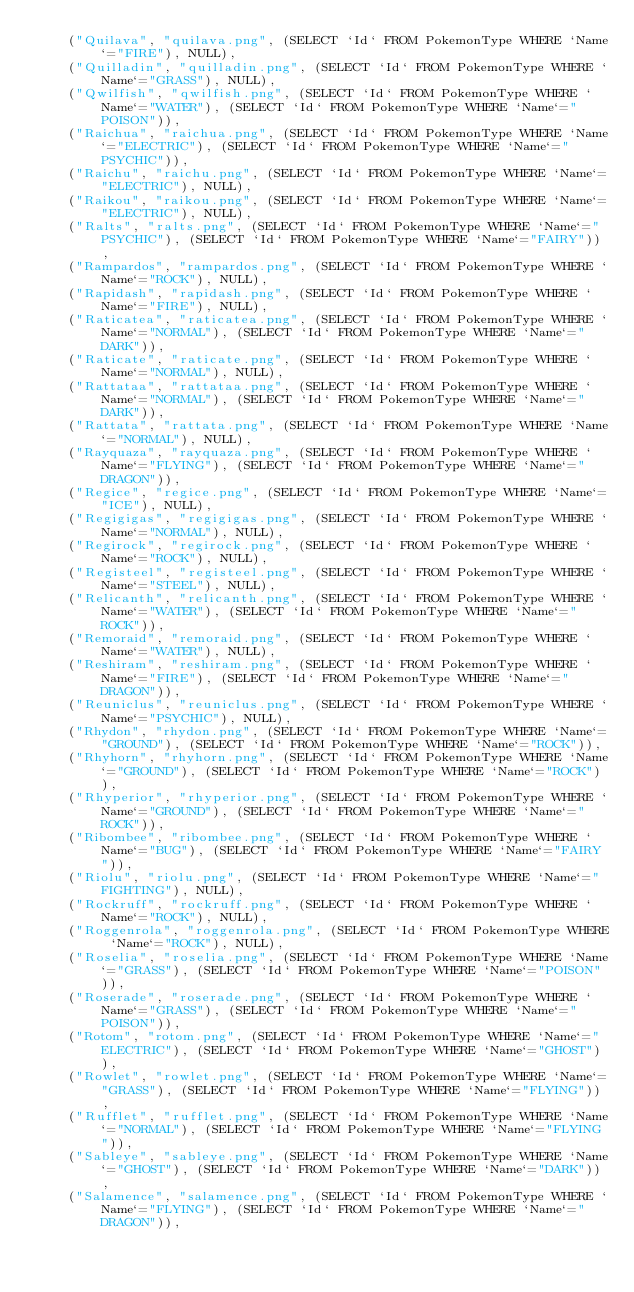<code> <loc_0><loc_0><loc_500><loc_500><_SQL_>	("Quilava", "quilava.png", (SELECT `Id` FROM PokemonType WHERE `Name`="FIRE"), NULL),
	("Quilladin", "quilladin.png", (SELECT `Id` FROM PokemonType WHERE `Name`="GRASS"), NULL),
	("Qwilfish", "qwilfish.png", (SELECT `Id` FROM PokemonType WHERE `Name`="WATER"), (SELECT `Id` FROM PokemonType WHERE `Name`="POISON")),
	("Raichua", "raichua.png", (SELECT `Id` FROM PokemonType WHERE `Name`="ELECTRIC"), (SELECT `Id` FROM PokemonType WHERE `Name`="PSYCHIC")),
	("Raichu", "raichu.png", (SELECT `Id` FROM PokemonType WHERE `Name`="ELECTRIC"), NULL),
	("Raikou", "raikou.png", (SELECT `Id` FROM PokemonType WHERE `Name`="ELECTRIC"), NULL),
	("Ralts", "ralts.png", (SELECT `Id` FROM PokemonType WHERE `Name`="PSYCHIC"), (SELECT `Id` FROM PokemonType WHERE `Name`="FAIRY")),
	("Rampardos", "rampardos.png", (SELECT `Id` FROM PokemonType WHERE `Name`="ROCK"), NULL),
	("Rapidash", "rapidash.png", (SELECT `Id` FROM PokemonType WHERE `Name`="FIRE"), NULL),
	("Raticatea", "raticatea.png", (SELECT `Id` FROM PokemonType WHERE `Name`="NORMAL"), (SELECT `Id` FROM PokemonType WHERE `Name`="DARK")),
	("Raticate", "raticate.png", (SELECT `Id` FROM PokemonType WHERE `Name`="NORMAL"), NULL),
	("Rattataa", "rattataa.png", (SELECT `Id` FROM PokemonType WHERE `Name`="NORMAL"), (SELECT `Id` FROM PokemonType WHERE `Name`="DARK")),
	("Rattata", "rattata.png", (SELECT `Id` FROM PokemonType WHERE `Name`="NORMAL"), NULL),
	("Rayquaza", "rayquaza.png", (SELECT `Id` FROM PokemonType WHERE `Name`="FLYING"), (SELECT `Id` FROM PokemonType WHERE `Name`="DRAGON")),
	("Regice", "regice.png", (SELECT `Id` FROM PokemonType WHERE `Name`="ICE"), NULL),
	("Regigigas", "regigigas.png", (SELECT `Id` FROM PokemonType WHERE `Name`="NORMAL"), NULL),
	("Regirock", "regirock.png", (SELECT `Id` FROM PokemonType WHERE `Name`="ROCK"), NULL),
	("Registeel", "registeel.png", (SELECT `Id` FROM PokemonType WHERE `Name`="STEEL"), NULL),
	("Relicanth", "relicanth.png", (SELECT `Id` FROM PokemonType WHERE `Name`="WATER"), (SELECT `Id` FROM PokemonType WHERE `Name`="ROCK")),
	("Remoraid", "remoraid.png", (SELECT `Id` FROM PokemonType WHERE `Name`="WATER"), NULL),
	("Reshiram", "reshiram.png", (SELECT `Id` FROM PokemonType WHERE `Name`="FIRE"), (SELECT `Id` FROM PokemonType WHERE `Name`="DRAGON")),
	("Reuniclus", "reuniclus.png", (SELECT `Id` FROM PokemonType WHERE `Name`="PSYCHIC"), NULL),
	("Rhydon", "rhydon.png", (SELECT `Id` FROM PokemonType WHERE `Name`="GROUND"), (SELECT `Id` FROM PokemonType WHERE `Name`="ROCK")),
	("Rhyhorn", "rhyhorn.png", (SELECT `Id` FROM PokemonType WHERE `Name`="GROUND"), (SELECT `Id` FROM PokemonType WHERE `Name`="ROCK")),
	("Rhyperior", "rhyperior.png", (SELECT `Id` FROM PokemonType WHERE `Name`="GROUND"), (SELECT `Id` FROM PokemonType WHERE `Name`="ROCK")),
	("Ribombee", "ribombee.png", (SELECT `Id` FROM PokemonType WHERE `Name`="BUG"), (SELECT `Id` FROM PokemonType WHERE `Name`="FAIRY")),
	("Riolu", "riolu.png", (SELECT `Id` FROM PokemonType WHERE `Name`="FIGHTING"), NULL),
	("Rockruff", "rockruff.png", (SELECT `Id` FROM PokemonType WHERE `Name`="ROCK"), NULL),
	("Roggenrola", "roggenrola.png", (SELECT `Id` FROM PokemonType WHERE `Name`="ROCK"), NULL),
	("Roselia", "roselia.png", (SELECT `Id` FROM PokemonType WHERE `Name`="GRASS"), (SELECT `Id` FROM PokemonType WHERE `Name`="POISON")),
	("Roserade", "roserade.png", (SELECT `Id` FROM PokemonType WHERE `Name`="GRASS"), (SELECT `Id` FROM PokemonType WHERE `Name`="POISON")),
	("Rotom", "rotom.png", (SELECT `Id` FROM PokemonType WHERE `Name`="ELECTRIC"), (SELECT `Id` FROM PokemonType WHERE `Name`="GHOST")),
	("Rowlet", "rowlet.png", (SELECT `Id` FROM PokemonType WHERE `Name`="GRASS"), (SELECT `Id` FROM PokemonType WHERE `Name`="FLYING")),
	("Rufflet", "rufflet.png", (SELECT `Id` FROM PokemonType WHERE `Name`="NORMAL"), (SELECT `Id` FROM PokemonType WHERE `Name`="FLYING")),
	("Sableye", "sableye.png", (SELECT `Id` FROM PokemonType WHERE `Name`="GHOST"), (SELECT `Id` FROM PokemonType WHERE `Name`="DARK")),
	("Salamence", "salamence.png", (SELECT `Id` FROM PokemonType WHERE `Name`="FLYING"), (SELECT `Id` FROM PokemonType WHERE `Name`="DRAGON")),</code> 